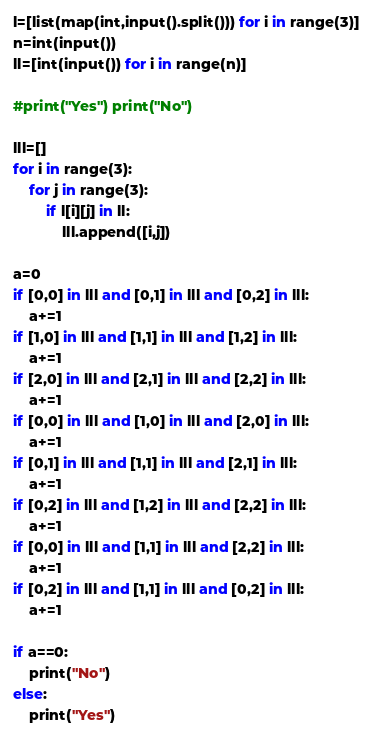<code> <loc_0><loc_0><loc_500><loc_500><_Python_>l=[list(map(int,input().split())) for i in range(3)]
n=int(input())
ll=[int(input()) for i in range(n)]

#print("Yes") print("No")

lll=[]
for i in range(3):
    for j in range(3):
        if l[i][j] in ll:
            lll.append([i,j])

a=0
if [0,0] in lll and [0,1] in lll and [0,2] in lll:
    a+=1
if [1,0] in lll and [1,1] in lll and [1,2] in lll:
    a+=1
if [2,0] in lll and [2,1] in lll and [2,2] in lll:
    a+=1
if [0,0] in lll and [1,0] in lll and [2,0] in lll:
    a+=1
if [0,1] in lll and [1,1] in lll and [2,1] in lll:
    a+=1
if [0,2] in lll and [1,2] in lll and [2,2] in lll:
    a+=1
if [0,0] in lll and [1,1] in lll and [2,2] in lll:
    a+=1
if [0,2] in lll and [1,1] in lll and [0,2] in lll:
    a+=1

if a==0:
    print("No")
else:
    print("Yes")</code> 